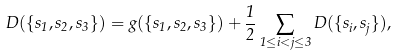<formula> <loc_0><loc_0><loc_500><loc_500>D ( \{ s _ { 1 } , s _ { 2 } , s _ { 3 } \} ) = g ( \{ s _ { 1 } , s _ { 2 } , s _ { 3 } \} ) + \frac { 1 } { 2 } \sum _ { 1 \leq i < j \leq 3 } D ( \{ s _ { i } , s _ { j } \} ) ,</formula> 